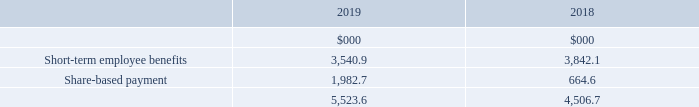Remuneration of key management personnel
The remuneration of the Directors, who are the key management personnel of the Group, is set out below in aggregate for each of the categories specified in IAS 24 ‘Related Party Disclosures’:
No Director received compensation for loss of office (2018 nil).
There were gains of $2,010,731 (2018 $852,742) on the exercise of options by key management personnel in 2019.
For further details refer to the Report on Directors’ remuneration on pages 77 to 101.
What were the gains on the exercise of options by key management personnel in 2019? $2,010,731. What is the share-based payment for 2019?
Answer scale should be: thousand. 1,982.7. What are the categories specified in IAS 24 ‘Related Party Disclosures’ in the table? Short-term employee benefits, share-based payment. In which year was the amount of short-term employee benefits larger? 3,842.1>3,540.9
Answer: 2018. What was the change in the total remuneration of key management personnel?
Answer scale should be: thousand. 5,523.6-4,506.7
Answer: 1016.9. What was the percentage change in the total remuneration of key management personnel?
Answer scale should be: percent. (5,523.6-4,506.7)/4,506.7
Answer: 22.56. 